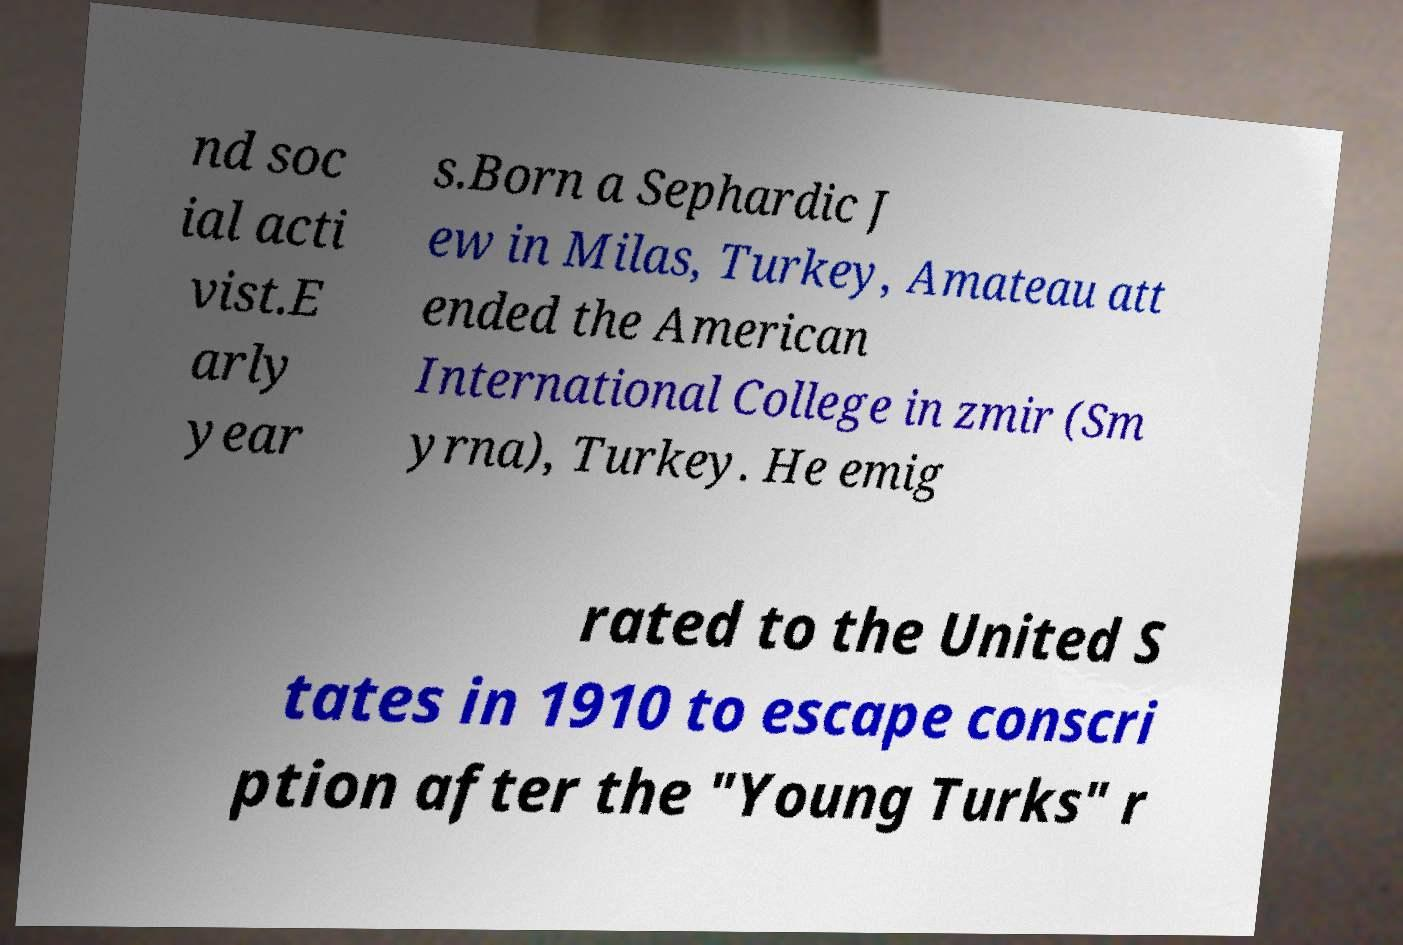Can you read and provide the text displayed in the image?This photo seems to have some interesting text. Can you extract and type it out for me? nd soc ial acti vist.E arly year s.Born a Sephardic J ew in Milas, Turkey, Amateau att ended the American International College in zmir (Sm yrna), Turkey. He emig rated to the United S tates in 1910 to escape conscri ption after the "Young Turks" r 